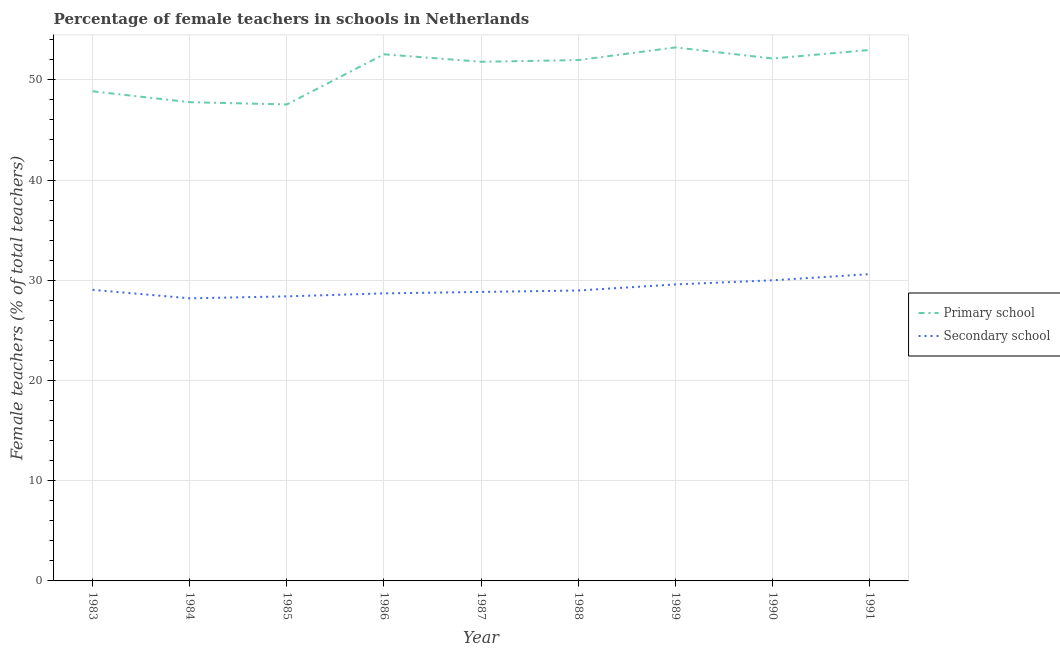How many different coloured lines are there?
Your answer should be compact. 2. Does the line corresponding to percentage of female teachers in primary schools intersect with the line corresponding to percentage of female teachers in secondary schools?
Your answer should be very brief. No. What is the percentage of female teachers in primary schools in 1986?
Offer a very short reply. 52.55. Across all years, what is the maximum percentage of female teachers in primary schools?
Keep it short and to the point. 53.24. Across all years, what is the minimum percentage of female teachers in secondary schools?
Make the answer very short. 28.2. In which year was the percentage of female teachers in secondary schools minimum?
Ensure brevity in your answer.  1984. What is the total percentage of female teachers in secondary schools in the graph?
Ensure brevity in your answer.  262.36. What is the difference between the percentage of female teachers in secondary schools in 1986 and that in 1988?
Offer a terse response. -0.29. What is the difference between the percentage of female teachers in primary schools in 1987 and the percentage of female teachers in secondary schools in 1990?
Offer a terse response. 21.8. What is the average percentage of female teachers in primary schools per year?
Keep it short and to the point. 50.99. In the year 1990, what is the difference between the percentage of female teachers in secondary schools and percentage of female teachers in primary schools?
Your response must be concise. -22.13. In how many years, is the percentage of female teachers in primary schools greater than 52 %?
Your answer should be very brief. 4. What is the ratio of the percentage of female teachers in primary schools in 1983 to that in 1989?
Make the answer very short. 0.92. Is the difference between the percentage of female teachers in primary schools in 1989 and 1990 greater than the difference between the percentage of female teachers in secondary schools in 1989 and 1990?
Keep it short and to the point. Yes. What is the difference between the highest and the second highest percentage of female teachers in secondary schools?
Keep it short and to the point. 0.61. What is the difference between the highest and the lowest percentage of female teachers in primary schools?
Your answer should be very brief. 5.69. In how many years, is the percentage of female teachers in secondary schools greater than the average percentage of female teachers in secondary schools taken over all years?
Offer a terse response. 3. Does the percentage of female teachers in primary schools monotonically increase over the years?
Offer a very short reply. No. Is the percentage of female teachers in secondary schools strictly greater than the percentage of female teachers in primary schools over the years?
Offer a very short reply. No. Is the percentage of female teachers in secondary schools strictly less than the percentage of female teachers in primary schools over the years?
Your answer should be very brief. Yes. How many years are there in the graph?
Keep it short and to the point. 9. Where does the legend appear in the graph?
Make the answer very short. Center right. What is the title of the graph?
Keep it short and to the point. Percentage of female teachers in schools in Netherlands. What is the label or title of the Y-axis?
Keep it short and to the point. Female teachers (% of total teachers). What is the Female teachers (% of total teachers) of Primary school in 1983?
Keep it short and to the point. 48.86. What is the Female teachers (% of total teachers) of Secondary school in 1983?
Your answer should be compact. 29.05. What is the Female teachers (% of total teachers) in Primary school in 1984?
Offer a very short reply. 47.77. What is the Female teachers (% of total teachers) of Secondary school in 1984?
Your response must be concise. 28.2. What is the Female teachers (% of total teachers) of Primary school in 1985?
Your answer should be compact. 47.55. What is the Female teachers (% of total teachers) of Secondary school in 1985?
Keep it short and to the point. 28.39. What is the Female teachers (% of total teachers) of Primary school in 1986?
Your answer should be compact. 52.55. What is the Female teachers (% of total teachers) of Secondary school in 1986?
Give a very brief answer. 28.69. What is the Female teachers (% of total teachers) in Primary school in 1987?
Provide a succinct answer. 51.8. What is the Female teachers (% of total teachers) in Secondary school in 1987?
Make the answer very short. 28.84. What is the Female teachers (% of total teachers) in Primary school in 1988?
Offer a terse response. 51.98. What is the Female teachers (% of total teachers) in Secondary school in 1988?
Your response must be concise. 28.98. What is the Female teachers (% of total teachers) of Primary school in 1989?
Provide a short and direct response. 53.24. What is the Female teachers (% of total teachers) in Secondary school in 1989?
Your response must be concise. 29.59. What is the Female teachers (% of total teachers) in Primary school in 1990?
Provide a succinct answer. 52.13. What is the Female teachers (% of total teachers) in Primary school in 1991?
Offer a very short reply. 52.98. What is the Female teachers (% of total teachers) in Secondary school in 1991?
Your answer should be very brief. 30.61. Across all years, what is the maximum Female teachers (% of total teachers) in Primary school?
Your response must be concise. 53.24. Across all years, what is the maximum Female teachers (% of total teachers) of Secondary school?
Offer a very short reply. 30.61. Across all years, what is the minimum Female teachers (% of total teachers) of Primary school?
Your response must be concise. 47.55. Across all years, what is the minimum Female teachers (% of total teachers) of Secondary school?
Give a very brief answer. 28.2. What is the total Female teachers (% of total teachers) of Primary school in the graph?
Ensure brevity in your answer.  458.87. What is the total Female teachers (% of total teachers) in Secondary school in the graph?
Offer a terse response. 262.36. What is the difference between the Female teachers (% of total teachers) in Primary school in 1983 and that in 1984?
Give a very brief answer. 1.08. What is the difference between the Female teachers (% of total teachers) in Secondary school in 1983 and that in 1984?
Your response must be concise. 0.85. What is the difference between the Female teachers (% of total teachers) in Primary school in 1983 and that in 1985?
Your answer should be compact. 1.31. What is the difference between the Female teachers (% of total teachers) of Secondary school in 1983 and that in 1985?
Ensure brevity in your answer.  0.66. What is the difference between the Female teachers (% of total teachers) of Primary school in 1983 and that in 1986?
Provide a succinct answer. -3.69. What is the difference between the Female teachers (% of total teachers) in Secondary school in 1983 and that in 1986?
Give a very brief answer. 0.36. What is the difference between the Female teachers (% of total teachers) in Primary school in 1983 and that in 1987?
Make the answer very short. -2.95. What is the difference between the Female teachers (% of total teachers) of Secondary school in 1983 and that in 1987?
Provide a succinct answer. 0.21. What is the difference between the Female teachers (% of total teachers) of Primary school in 1983 and that in 1988?
Offer a very short reply. -3.12. What is the difference between the Female teachers (% of total teachers) of Secondary school in 1983 and that in 1988?
Keep it short and to the point. 0.07. What is the difference between the Female teachers (% of total teachers) in Primary school in 1983 and that in 1989?
Keep it short and to the point. -4.38. What is the difference between the Female teachers (% of total teachers) of Secondary school in 1983 and that in 1989?
Your response must be concise. -0.54. What is the difference between the Female teachers (% of total teachers) in Primary school in 1983 and that in 1990?
Your response must be concise. -3.28. What is the difference between the Female teachers (% of total teachers) of Secondary school in 1983 and that in 1990?
Provide a succinct answer. -0.95. What is the difference between the Female teachers (% of total teachers) of Primary school in 1983 and that in 1991?
Keep it short and to the point. -4.12. What is the difference between the Female teachers (% of total teachers) of Secondary school in 1983 and that in 1991?
Provide a succinct answer. -1.56. What is the difference between the Female teachers (% of total teachers) in Primary school in 1984 and that in 1985?
Your answer should be very brief. 0.23. What is the difference between the Female teachers (% of total teachers) of Secondary school in 1984 and that in 1985?
Provide a succinct answer. -0.19. What is the difference between the Female teachers (% of total teachers) in Primary school in 1984 and that in 1986?
Give a very brief answer. -4.78. What is the difference between the Female teachers (% of total teachers) of Secondary school in 1984 and that in 1986?
Offer a very short reply. -0.49. What is the difference between the Female teachers (% of total teachers) of Primary school in 1984 and that in 1987?
Offer a terse response. -4.03. What is the difference between the Female teachers (% of total teachers) of Secondary school in 1984 and that in 1987?
Give a very brief answer. -0.64. What is the difference between the Female teachers (% of total teachers) in Primary school in 1984 and that in 1988?
Offer a very short reply. -4.2. What is the difference between the Female teachers (% of total teachers) in Secondary school in 1984 and that in 1988?
Offer a terse response. -0.78. What is the difference between the Female teachers (% of total teachers) in Primary school in 1984 and that in 1989?
Make the answer very short. -5.46. What is the difference between the Female teachers (% of total teachers) in Secondary school in 1984 and that in 1989?
Keep it short and to the point. -1.39. What is the difference between the Female teachers (% of total teachers) in Primary school in 1984 and that in 1990?
Make the answer very short. -4.36. What is the difference between the Female teachers (% of total teachers) of Secondary school in 1984 and that in 1990?
Provide a succinct answer. -1.8. What is the difference between the Female teachers (% of total teachers) in Primary school in 1984 and that in 1991?
Make the answer very short. -5.21. What is the difference between the Female teachers (% of total teachers) of Secondary school in 1984 and that in 1991?
Provide a succinct answer. -2.41. What is the difference between the Female teachers (% of total teachers) in Primary school in 1985 and that in 1986?
Ensure brevity in your answer.  -5.01. What is the difference between the Female teachers (% of total teachers) of Secondary school in 1985 and that in 1986?
Provide a succinct answer. -0.3. What is the difference between the Female teachers (% of total teachers) of Primary school in 1985 and that in 1987?
Provide a short and direct response. -4.26. What is the difference between the Female teachers (% of total teachers) in Secondary school in 1985 and that in 1987?
Your answer should be very brief. -0.44. What is the difference between the Female teachers (% of total teachers) in Primary school in 1985 and that in 1988?
Offer a very short reply. -4.43. What is the difference between the Female teachers (% of total teachers) in Secondary school in 1985 and that in 1988?
Offer a very short reply. -0.59. What is the difference between the Female teachers (% of total teachers) in Primary school in 1985 and that in 1989?
Make the answer very short. -5.69. What is the difference between the Female teachers (% of total teachers) in Secondary school in 1985 and that in 1989?
Provide a short and direct response. -1.19. What is the difference between the Female teachers (% of total teachers) in Primary school in 1985 and that in 1990?
Your answer should be very brief. -4.59. What is the difference between the Female teachers (% of total teachers) in Secondary school in 1985 and that in 1990?
Give a very brief answer. -1.61. What is the difference between the Female teachers (% of total teachers) in Primary school in 1985 and that in 1991?
Keep it short and to the point. -5.44. What is the difference between the Female teachers (% of total teachers) of Secondary school in 1985 and that in 1991?
Your response must be concise. -2.22. What is the difference between the Female teachers (% of total teachers) of Primary school in 1986 and that in 1987?
Your answer should be compact. 0.75. What is the difference between the Female teachers (% of total teachers) in Secondary school in 1986 and that in 1987?
Your answer should be very brief. -0.14. What is the difference between the Female teachers (% of total teachers) of Primary school in 1986 and that in 1988?
Give a very brief answer. 0.58. What is the difference between the Female teachers (% of total teachers) in Secondary school in 1986 and that in 1988?
Offer a very short reply. -0.29. What is the difference between the Female teachers (% of total teachers) of Primary school in 1986 and that in 1989?
Your answer should be very brief. -0.68. What is the difference between the Female teachers (% of total teachers) in Secondary school in 1986 and that in 1989?
Offer a very short reply. -0.89. What is the difference between the Female teachers (% of total teachers) in Primary school in 1986 and that in 1990?
Make the answer very short. 0.42. What is the difference between the Female teachers (% of total teachers) of Secondary school in 1986 and that in 1990?
Keep it short and to the point. -1.31. What is the difference between the Female teachers (% of total teachers) of Primary school in 1986 and that in 1991?
Give a very brief answer. -0.43. What is the difference between the Female teachers (% of total teachers) in Secondary school in 1986 and that in 1991?
Keep it short and to the point. -1.92. What is the difference between the Female teachers (% of total teachers) of Primary school in 1987 and that in 1988?
Give a very brief answer. -0.17. What is the difference between the Female teachers (% of total teachers) in Secondary school in 1987 and that in 1988?
Provide a succinct answer. -0.14. What is the difference between the Female teachers (% of total teachers) of Primary school in 1987 and that in 1989?
Ensure brevity in your answer.  -1.43. What is the difference between the Female teachers (% of total teachers) of Secondary school in 1987 and that in 1989?
Offer a terse response. -0.75. What is the difference between the Female teachers (% of total teachers) of Primary school in 1987 and that in 1990?
Offer a terse response. -0.33. What is the difference between the Female teachers (% of total teachers) in Secondary school in 1987 and that in 1990?
Make the answer very short. -1.16. What is the difference between the Female teachers (% of total teachers) in Primary school in 1987 and that in 1991?
Offer a very short reply. -1.18. What is the difference between the Female teachers (% of total teachers) in Secondary school in 1987 and that in 1991?
Offer a terse response. -1.78. What is the difference between the Female teachers (% of total teachers) in Primary school in 1988 and that in 1989?
Provide a short and direct response. -1.26. What is the difference between the Female teachers (% of total teachers) in Secondary school in 1988 and that in 1989?
Offer a terse response. -0.61. What is the difference between the Female teachers (% of total teachers) of Primary school in 1988 and that in 1990?
Provide a short and direct response. -0.16. What is the difference between the Female teachers (% of total teachers) in Secondary school in 1988 and that in 1990?
Ensure brevity in your answer.  -1.02. What is the difference between the Female teachers (% of total teachers) of Primary school in 1988 and that in 1991?
Give a very brief answer. -1.01. What is the difference between the Female teachers (% of total teachers) in Secondary school in 1988 and that in 1991?
Make the answer very short. -1.63. What is the difference between the Female teachers (% of total teachers) of Primary school in 1989 and that in 1990?
Your answer should be compact. 1.1. What is the difference between the Female teachers (% of total teachers) in Secondary school in 1989 and that in 1990?
Your response must be concise. -0.41. What is the difference between the Female teachers (% of total teachers) in Primary school in 1989 and that in 1991?
Make the answer very short. 0.26. What is the difference between the Female teachers (% of total teachers) in Secondary school in 1989 and that in 1991?
Your response must be concise. -1.03. What is the difference between the Female teachers (% of total teachers) in Primary school in 1990 and that in 1991?
Ensure brevity in your answer.  -0.85. What is the difference between the Female teachers (% of total teachers) of Secondary school in 1990 and that in 1991?
Offer a very short reply. -0.61. What is the difference between the Female teachers (% of total teachers) of Primary school in 1983 and the Female teachers (% of total teachers) of Secondary school in 1984?
Your answer should be compact. 20.66. What is the difference between the Female teachers (% of total teachers) in Primary school in 1983 and the Female teachers (% of total teachers) in Secondary school in 1985?
Your response must be concise. 20.46. What is the difference between the Female teachers (% of total teachers) in Primary school in 1983 and the Female teachers (% of total teachers) in Secondary school in 1986?
Ensure brevity in your answer.  20.16. What is the difference between the Female teachers (% of total teachers) of Primary school in 1983 and the Female teachers (% of total teachers) of Secondary school in 1987?
Provide a succinct answer. 20.02. What is the difference between the Female teachers (% of total teachers) of Primary school in 1983 and the Female teachers (% of total teachers) of Secondary school in 1988?
Give a very brief answer. 19.88. What is the difference between the Female teachers (% of total teachers) in Primary school in 1983 and the Female teachers (% of total teachers) in Secondary school in 1989?
Your answer should be compact. 19.27. What is the difference between the Female teachers (% of total teachers) in Primary school in 1983 and the Female teachers (% of total teachers) in Secondary school in 1990?
Your answer should be compact. 18.86. What is the difference between the Female teachers (% of total teachers) of Primary school in 1983 and the Female teachers (% of total teachers) of Secondary school in 1991?
Give a very brief answer. 18.24. What is the difference between the Female teachers (% of total teachers) of Primary school in 1984 and the Female teachers (% of total teachers) of Secondary school in 1985?
Offer a very short reply. 19.38. What is the difference between the Female teachers (% of total teachers) of Primary school in 1984 and the Female teachers (% of total teachers) of Secondary school in 1986?
Provide a short and direct response. 19.08. What is the difference between the Female teachers (% of total teachers) of Primary school in 1984 and the Female teachers (% of total teachers) of Secondary school in 1987?
Your response must be concise. 18.94. What is the difference between the Female teachers (% of total teachers) of Primary school in 1984 and the Female teachers (% of total teachers) of Secondary school in 1988?
Keep it short and to the point. 18.79. What is the difference between the Female teachers (% of total teachers) in Primary school in 1984 and the Female teachers (% of total teachers) in Secondary school in 1989?
Keep it short and to the point. 18.19. What is the difference between the Female teachers (% of total teachers) of Primary school in 1984 and the Female teachers (% of total teachers) of Secondary school in 1990?
Offer a terse response. 17.77. What is the difference between the Female teachers (% of total teachers) in Primary school in 1984 and the Female teachers (% of total teachers) in Secondary school in 1991?
Make the answer very short. 17.16. What is the difference between the Female teachers (% of total teachers) of Primary school in 1985 and the Female teachers (% of total teachers) of Secondary school in 1986?
Keep it short and to the point. 18.85. What is the difference between the Female teachers (% of total teachers) in Primary school in 1985 and the Female teachers (% of total teachers) in Secondary school in 1987?
Ensure brevity in your answer.  18.71. What is the difference between the Female teachers (% of total teachers) of Primary school in 1985 and the Female teachers (% of total teachers) of Secondary school in 1988?
Your answer should be compact. 18.57. What is the difference between the Female teachers (% of total teachers) in Primary school in 1985 and the Female teachers (% of total teachers) in Secondary school in 1989?
Provide a short and direct response. 17.96. What is the difference between the Female teachers (% of total teachers) of Primary school in 1985 and the Female teachers (% of total teachers) of Secondary school in 1990?
Make the answer very short. 17.55. What is the difference between the Female teachers (% of total teachers) in Primary school in 1985 and the Female teachers (% of total teachers) in Secondary school in 1991?
Make the answer very short. 16.93. What is the difference between the Female teachers (% of total teachers) of Primary school in 1986 and the Female teachers (% of total teachers) of Secondary school in 1987?
Ensure brevity in your answer.  23.72. What is the difference between the Female teachers (% of total teachers) of Primary school in 1986 and the Female teachers (% of total teachers) of Secondary school in 1988?
Offer a terse response. 23.57. What is the difference between the Female teachers (% of total teachers) of Primary school in 1986 and the Female teachers (% of total teachers) of Secondary school in 1989?
Make the answer very short. 22.97. What is the difference between the Female teachers (% of total teachers) of Primary school in 1986 and the Female teachers (% of total teachers) of Secondary school in 1990?
Keep it short and to the point. 22.55. What is the difference between the Female teachers (% of total teachers) in Primary school in 1986 and the Female teachers (% of total teachers) in Secondary school in 1991?
Provide a succinct answer. 21.94. What is the difference between the Female teachers (% of total teachers) of Primary school in 1987 and the Female teachers (% of total teachers) of Secondary school in 1988?
Ensure brevity in your answer.  22.82. What is the difference between the Female teachers (% of total teachers) of Primary school in 1987 and the Female teachers (% of total teachers) of Secondary school in 1989?
Provide a short and direct response. 22.22. What is the difference between the Female teachers (% of total teachers) in Primary school in 1987 and the Female teachers (% of total teachers) in Secondary school in 1990?
Provide a succinct answer. 21.8. What is the difference between the Female teachers (% of total teachers) of Primary school in 1987 and the Female teachers (% of total teachers) of Secondary school in 1991?
Keep it short and to the point. 21.19. What is the difference between the Female teachers (% of total teachers) of Primary school in 1988 and the Female teachers (% of total teachers) of Secondary school in 1989?
Offer a very short reply. 22.39. What is the difference between the Female teachers (% of total teachers) of Primary school in 1988 and the Female teachers (% of total teachers) of Secondary school in 1990?
Your response must be concise. 21.98. What is the difference between the Female teachers (% of total teachers) in Primary school in 1988 and the Female teachers (% of total teachers) in Secondary school in 1991?
Offer a very short reply. 21.36. What is the difference between the Female teachers (% of total teachers) of Primary school in 1989 and the Female teachers (% of total teachers) of Secondary school in 1990?
Offer a terse response. 23.24. What is the difference between the Female teachers (% of total teachers) in Primary school in 1989 and the Female teachers (% of total teachers) in Secondary school in 1991?
Ensure brevity in your answer.  22.62. What is the difference between the Female teachers (% of total teachers) of Primary school in 1990 and the Female teachers (% of total teachers) of Secondary school in 1991?
Your answer should be very brief. 21.52. What is the average Female teachers (% of total teachers) in Primary school per year?
Your response must be concise. 50.99. What is the average Female teachers (% of total teachers) of Secondary school per year?
Make the answer very short. 29.15. In the year 1983, what is the difference between the Female teachers (% of total teachers) in Primary school and Female teachers (% of total teachers) in Secondary school?
Make the answer very short. 19.81. In the year 1984, what is the difference between the Female teachers (% of total teachers) of Primary school and Female teachers (% of total teachers) of Secondary school?
Ensure brevity in your answer.  19.57. In the year 1985, what is the difference between the Female teachers (% of total teachers) of Primary school and Female teachers (% of total teachers) of Secondary school?
Keep it short and to the point. 19.15. In the year 1986, what is the difference between the Female teachers (% of total teachers) of Primary school and Female teachers (% of total teachers) of Secondary school?
Offer a very short reply. 23.86. In the year 1987, what is the difference between the Female teachers (% of total teachers) of Primary school and Female teachers (% of total teachers) of Secondary school?
Provide a short and direct response. 22.97. In the year 1988, what is the difference between the Female teachers (% of total teachers) in Primary school and Female teachers (% of total teachers) in Secondary school?
Give a very brief answer. 23. In the year 1989, what is the difference between the Female teachers (% of total teachers) in Primary school and Female teachers (% of total teachers) in Secondary school?
Your answer should be very brief. 23.65. In the year 1990, what is the difference between the Female teachers (% of total teachers) of Primary school and Female teachers (% of total teachers) of Secondary school?
Offer a terse response. 22.13. In the year 1991, what is the difference between the Female teachers (% of total teachers) of Primary school and Female teachers (% of total teachers) of Secondary school?
Offer a terse response. 22.37. What is the ratio of the Female teachers (% of total teachers) in Primary school in 1983 to that in 1984?
Ensure brevity in your answer.  1.02. What is the ratio of the Female teachers (% of total teachers) in Secondary school in 1983 to that in 1984?
Your answer should be very brief. 1.03. What is the ratio of the Female teachers (% of total teachers) of Primary school in 1983 to that in 1985?
Offer a terse response. 1.03. What is the ratio of the Female teachers (% of total teachers) in Secondary school in 1983 to that in 1985?
Your answer should be compact. 1.02. What is the ratio of the Female teachers (% of total teachers) of Primary school in 1983 to that in 1986?
Provide a short and direct response. 0.93. What is the ratio of the Female teachers (% of total teachers) of Secondary school in 1983 to that in 1986?
Keep it short and to the point. 1.01. What is the ratio of the Female teachers (% of total teachers) in Primary school in 1983 to that in 1987?
Offer a terse response. 0.94. What is the ratio of the Female teachers (% of total teachers) in Secondary school in 1983 to that in 1987?
Your answer should be very brief. 1.01. What is the ratio of the Female teachers (% of total teachers) of Primary school in 1983 to that in 1988?
Your response must be concise. 0.94. What is the ratio of the Female teachers (% of total teachers) in Primary school in 1983 to that in 1989?
Offer a very short reply. 0.92. What is the ratio of the Female teachers (% of total teachers) in Secondary school in 1983 to that in 1989?
Ensure brevity in your answer.  0.98. What is the ratio of the Female teachers (% of total teachers) of Primary school in 1983 to that in 1990?
Keep it short and to the point. 0.94. What is the ratio of the Female teachers (% of total teachers) of Secondary school in 1983 to that in 1990?
Your answer should be compact. 0.97. What is the ratio of the Female teachers (% of total teachers) of Primary school in 1983 to that in 1991?
Keep it short and to the point. 0.92. What is the ratio of the Female teachers (% of total teachers) of Secondary school in 1983 to that in 1991?
Give a very brief answer. 0.95. What is the ratio of the Female teachers (% of total teachers) in Secondary school in 1984 to that in 1986?
Offer a terse response. 0.98. What is the ratio of the Female teachers (% of total teachers) of Primary school in 1984 to that in 1987?
Provide a short and direct response. 0.92. What is the ratio of the Female teachers (% of total teachers) of Secondary school in 1984 to that in 1987?
Ensure brevity in your answer.  0.98. What is the ratio of the Female teachers (% of total teachers) in Primary school in 1984 to that in 1988?
Provide a succinct answer. 0.92. What is the ratio of the Female teachers (% of total teachers) of Secondary school in 1984 to that in 1988?
Provide a short and direct response. 0.97. What is the ratio of the Female teachers (% of total teachers) in Primary school in 1984 to that in 1989?
Your answer should be very brief. 0.9. What is the ratio of the Female teachers (% of total teachers) of Secondary school in 1984 to that in 1989?
Provide a short and direct response. 0.95. What is the ratio of the Female teachers (% of total teachers) in Primary school in 1984 to that in 1990?
Make the answer very short. 0.92. What is the ratio of the Female teachers (% of total teachers) in Primary school in 1984 to that in 1991?
Offer a terse response. 0.9. What is the ratio of the Female teachers (% of total teachers) in Secondary school in 1984 to that in 1991?
Ensure brevity in your answer.  0.92. What is the ratio of the Female teachers (% of total teachers) in Primary school in 1985 to that in 1986?
Provide a short and direct response. 0.9. What is the ratio of the Female teachers (% of total teachers) in Secondary school in 1985 to that in 1986?
Your answer should be compact. 0.99. What is the ratio of the Female teachers (% of total teachers) of Primary school in 1985 to that in 1987?
Provide a succinct answer. 0.92. What is the ratio of the Female teachers (% of total teachers) in Secondary school in 1985 to that in 1987?
Your answer should be compact. 0.98. What is the ratio of the Female teachers (% of total teachers) of Primary school in 1985 to that in 1988?
Make the answer very short. 0.91. What is the ratio of the Female teachers (% of total teachers) of Secondary school in 1985 to that in 1988?
Keep it short and to the point. 0.98. What is the ratio of the Female teachers (% of total teachers) in Primary school in 1985 to that in 1989?
Offer a very short reply. 0.89. What is the ratio of the Female teachers (% of total teachers) in Secondary school in 1985 to that in 1989?
Provide a succinct answer. 0.96. What is the ratio of the Female teachers (% of total teachers) in Primary school in 1985 to that in 1990?
Your answer should be compact. 0.91. What is the ratio of the Female teachers (% of total teachers) of Secondary school in 1985 to that in 1990?
Provide a short and direct response. 0.95. What is the ratio of the Female teachers (% of total teachers) of Primary school in 1985 to that in 1991?
Your answer should be compact. 0.9. What is the ratio of the Female teachers (% of total teachers) of Secondary school in 1985 to that in 1991?
Make the answer very short. 0.93. What is the ratio of the Female teachers (% of total teachers) in Primary school in 1986 to that in 1987?
Your answer should be compact. 1.01. What is the ratio of the Female teachers (% of total teachers) of Secondary school in 1986 to that in 1987?
Your answer should be compact. 0.99. What is the ratio of the Female teachers (% of total teachers) of Primary school in 1986 to that in 1988?
Ensure brevity in your answer.  1.01. What is the ratio of the Female teachers (% of total teachers) of Primary school in 1986 to that in 1989?
Your answer should be very brief. 0.99. What is the ratio of the Female teachers (% of total teachers) of Secondary school in 1986 to that in 1989?
Your response must be concise. 0.97. What is the ratio of the Female teachers (% of total teachers) of Secondary school in 1986 to that in 1990?
Make the answer very short. 0.96. What is the ratio of the Female teachers (% of total teachers) of Secondary school in 1986 to that in 1991?
Give a very brief answer. 0.94. What is the ratio of the Female teachers (% of total teachers) in Primary school in 1987 to that in 1988?
Offer a very short reply. 1. What is the ratio of the Female teachers (% of total teachers) in Primary school in 1987 to that in 1989?
Offer a very short reply. 0.97. What is the ratio of the Female teachers (% of total teachers) of Secondary school in 1987 to that in 1989?
Provide a succinct answer. 0.97. What is the ratio of the Female teachers (% of total teachers) in Primary school in 1987 to that in 1990?
Your answer should be very brief. 0.99. What is the ratio of the Female teachers (% of total teachers) in Secondary school in 1987 to that in 1990?
Offer a terse response. 0.96. What is the ratio of the Female teachers (% of total teachers) in Primary school in 1987 to that in 1991?
Your answer should be compact. 0.98. What is the ratio of the Female teachers (% of total teachers) in Secondary school in 1987 to that in 1991?
Offer a terse response. 0.94. What is the ratio of the Female teachers (% of total teachers) of Primary school in 1988 to that in 1989?
Offer a very short reply. 0.98. What is the ratio of the Female teachers (% of total teachers) of Secondary school in 1988 to that in 1989?
Give a very brief answer. 0.98. What is the ratio of the Female teachers (% of total teachers) in Secondary school in 1988 to that in 1991?
Your answer should be compact. 0.95. What is the ratio of the Female teachers (% of total teachers) of Primary school in 1989 to that in 1990?
Your answer should be very brief. 1.02. What is the ratio of the Female teachers (% of total teachers) in Secondary school in 1989 to that in 1990?
Ensure brevity in your answer.  0.99. What is the ratio of the Female teachers (% of total teachers) of Secondary school in 1989 to that in 1991?
Offer a terse response. 0.97. What is the ratio of the Female teachers (% of total teachers) in Primary school in 1990 to that in 1991?
Provide a succinct answer. 0.98. What is the difference between the highest and the second highest Female teachers (% of total teachers) of Primary school?
Your response must be concise. 0.26. What is the difference between the highest and the second highest Female teachers (% of total teachers) of Secondary school?
Offer a terse response. 0.61. What is the difference between the highest and the lowest Female teachers (% of total teachers) in Primary school?
Make the answer very short. 5.69. What is the difference between the highest and the lowest Female teachers (% of total teachers) in Secondary school?
Provide a short and direct response. 2.41. 